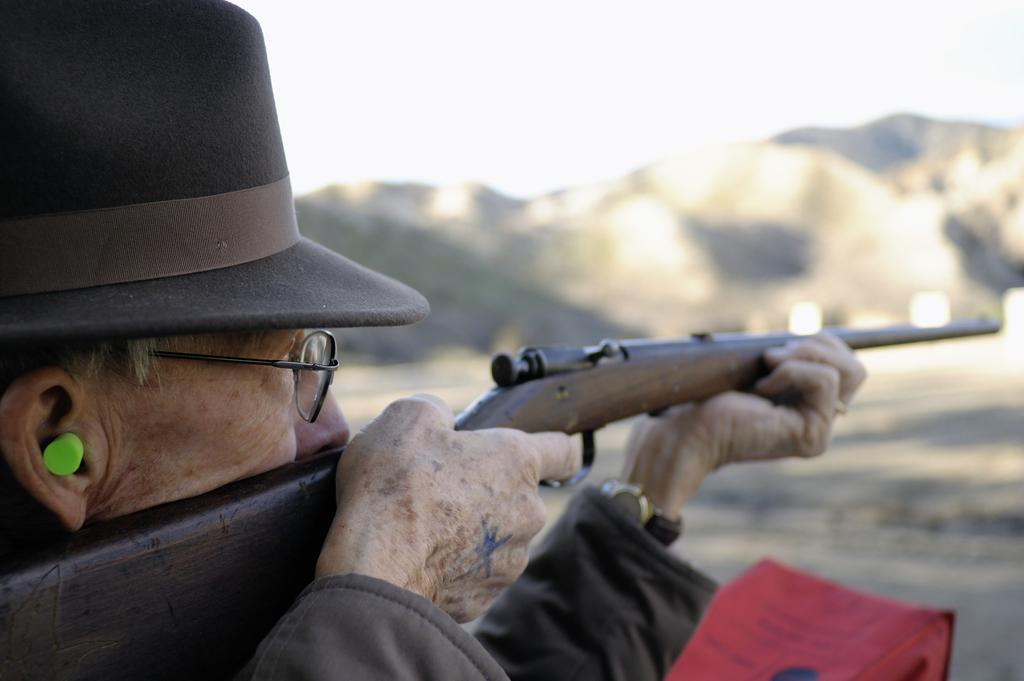Who is present in the image? There is a person in the image. What is the person holding in the image? The person is holding a gun. Can you describe the person's appearance? The person is wearing spectacles. What can be seen in the background of the image? There is a mountain and the sky visible in the background of the image. How many socks can be seen on the person's feet in the image? There is no information about socks or the person's feet in the image. 